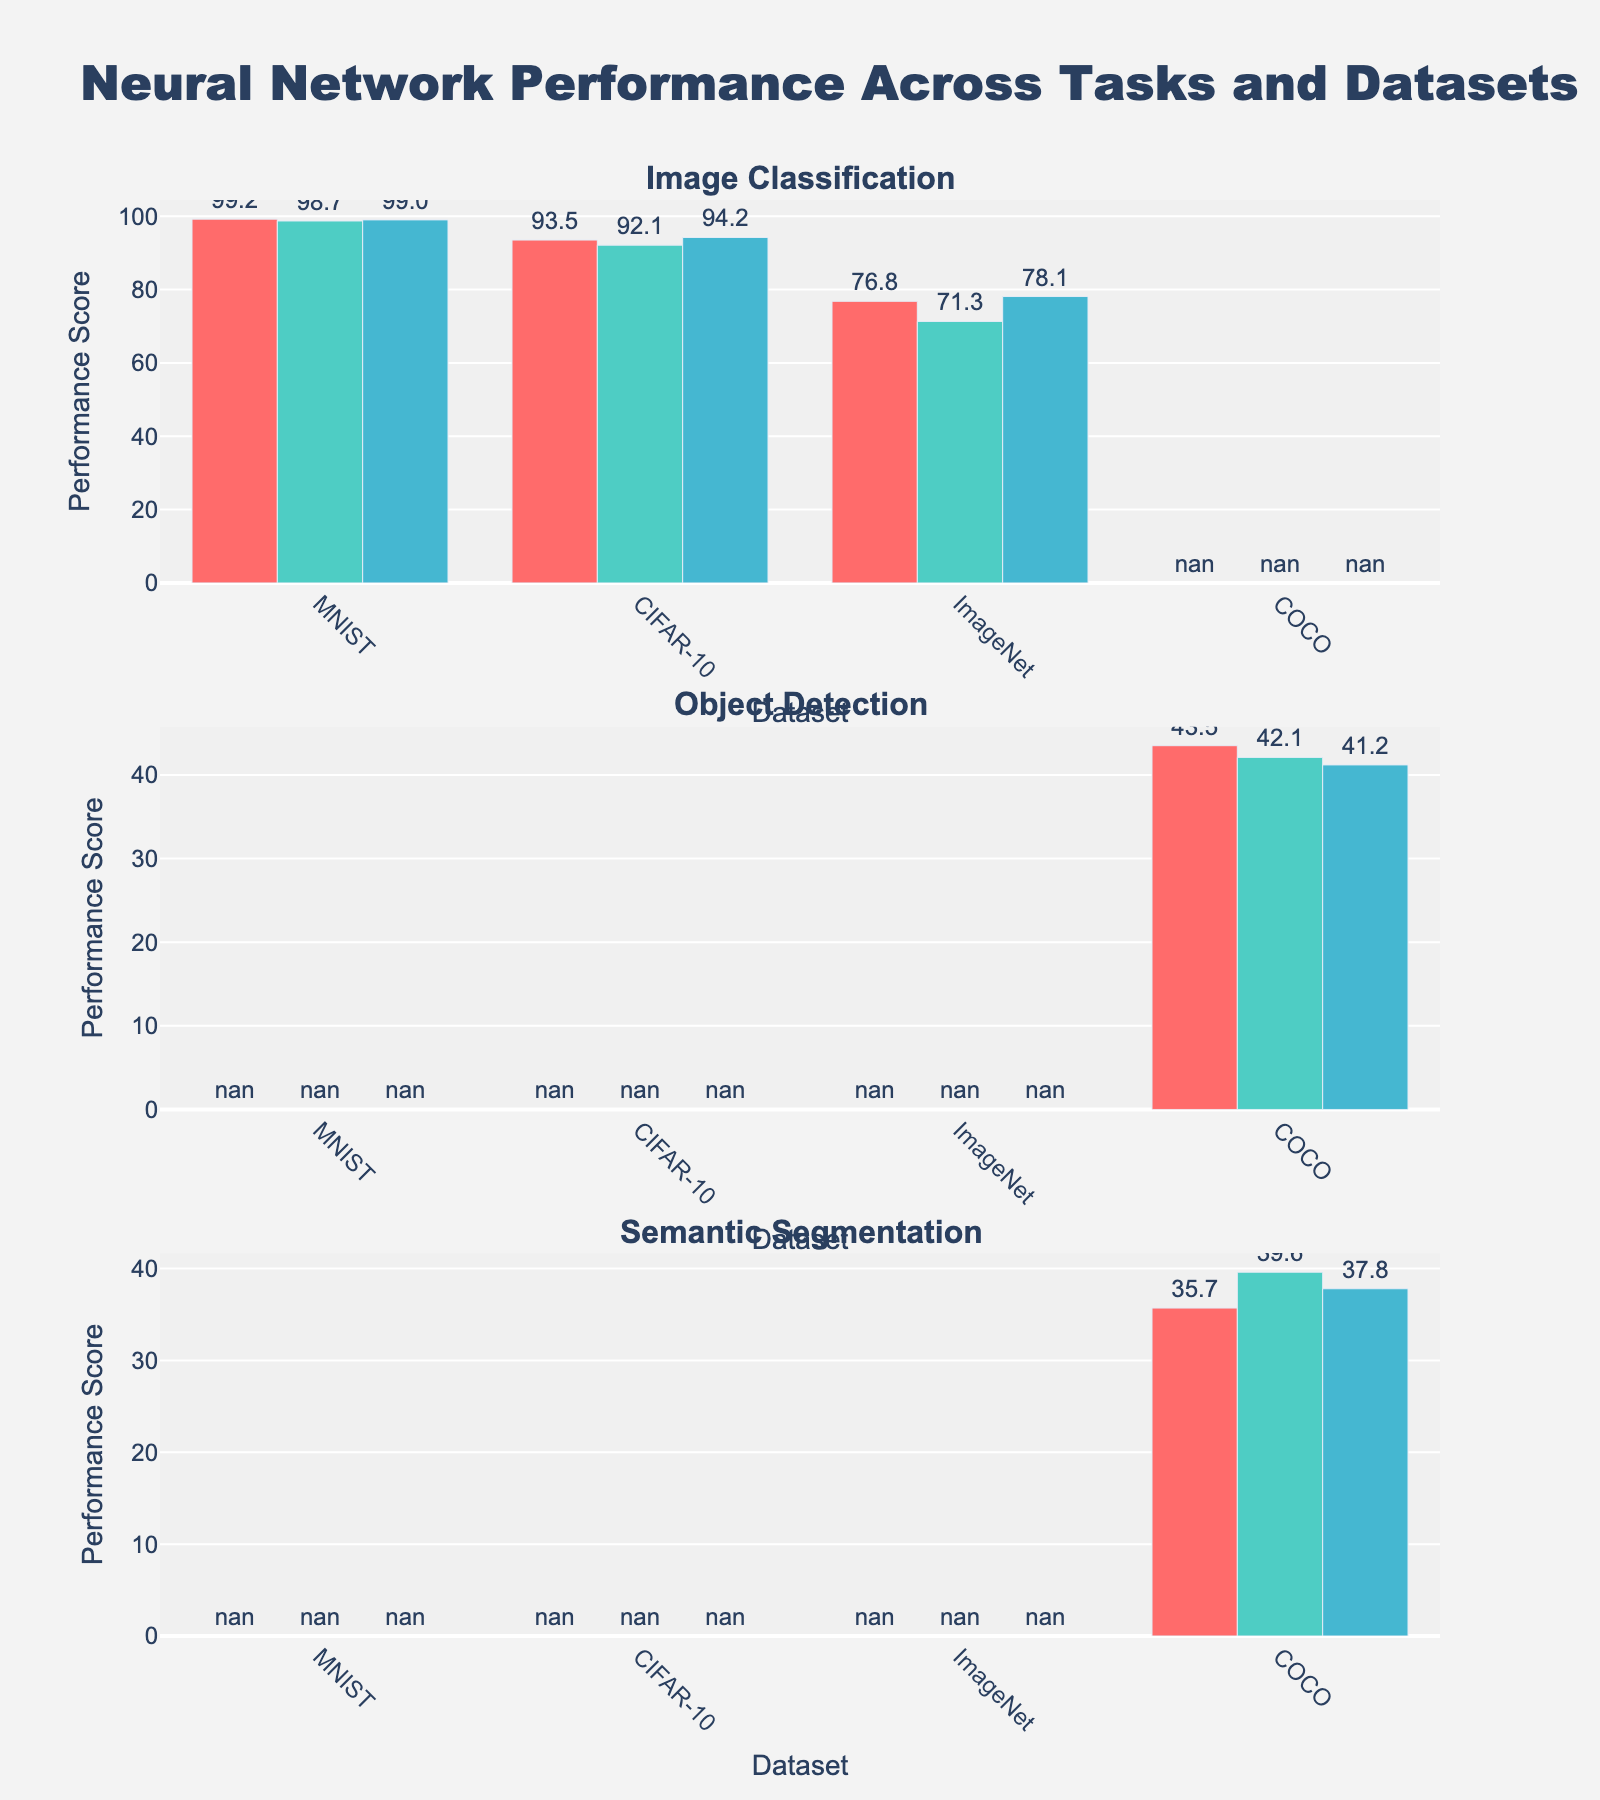What task has the subplot with the highest title and which models are represented in this subplot? The subplot titles are bold and clearly visible at the top of each subplot. The highest title in the plot indicates the first subplot, which corresponds to the first task in the dataset. By looking at the data, the "Image Classification" task appears first, and is represented by models like ResNet-50, VGG-16, and Inception-v3.
Answer: Image Classification - ResNet-50, VGG-16, Inception-v3 What is the color of the bars representing the YOLO-v5 model in the Object Detection subplot? Each model is represented by a bar in a specific color. For the YOLO-v5 model in the Object Detection subplot, the color can be identified by looking at the color differentiation among the models listed under the Object Detection task. According to the colors list in the code, the first color used is '#FF6B6B', which corresponds to YOLO-v5 as the first model in the Object Detection task.
Answer: Red (#FF6B6B) Which neural network model achieved the highest performance score on the CIFAR-10 dataset, and what was the score? By looking at the CIFAR-10 dataset in the "Image Classification" subplot, we compare the heights of the bars. The highest bar in the CIFAR-10 data belongs to the Inception-v3 model, with a performance score annotated above the bar. This can directly be verified in the data provided where Inception-v3 has a score of 94.2.
Answer: Inception-v3, 94.2 Compare the performance of ResNet-50 and VGG-16 on ImageNet dataset. Which one performs better and by how much? Looking at the ImageNet dataset in the "Image Classification" subplot, observe the relative heights of the bars for ResNet-50 and VGG-16 models. From the data provided, ResNet-50 scores 76.8 while VGG-16 scores 71.3. Subtract the VGG-16 score from the ResNet-50 score to find the difference.
Answer: ResNet-50 performs better by 5.5 Which task has the lowest average performance score based on the models compared, and what is the average score? To compute the average performance score, we calculate the mean of the scores for each task's models. For "Image Classification", the scores are 99.2, 98.7, and 99. The average is (99.2 + 98.7 + 99)/3. For "Object Detection", the scores are 43.5, 42.1, and 41.2. The average is (43.5+42.1+41.2)/3. For "Semantic Segmentation", the scores are 35.7, 39.6, and 37.8. The average is (35.7+39.6+37.8)/3. Comparing these averages, "Semantic Segmentation" has the lowest average score. Calculation: (35.7 + 39.6 + 37.8)/3 ≈ 37.7.
Answer: Semantic Segmentation, 37.7 